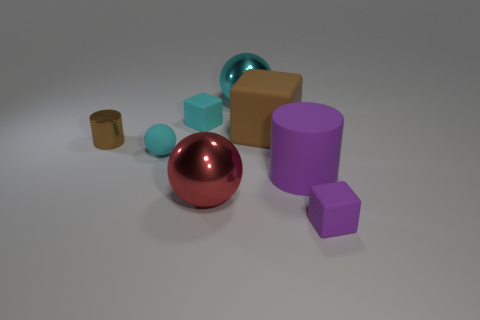Add 1 brown cubes. How many objects exist? 9 Subtract all balls. How many objects are left? 5 Subtract all small cyan rubber blocks. Subtract all matte balls. How many objects are left? 6 Add 2 small purple matte cubes. How many small purple matte cubes are left? 3 Add 6 small blue rubber things. How many small blue rubber things exist? 6 Subtract 1 red balls. How many objects are left? 7 